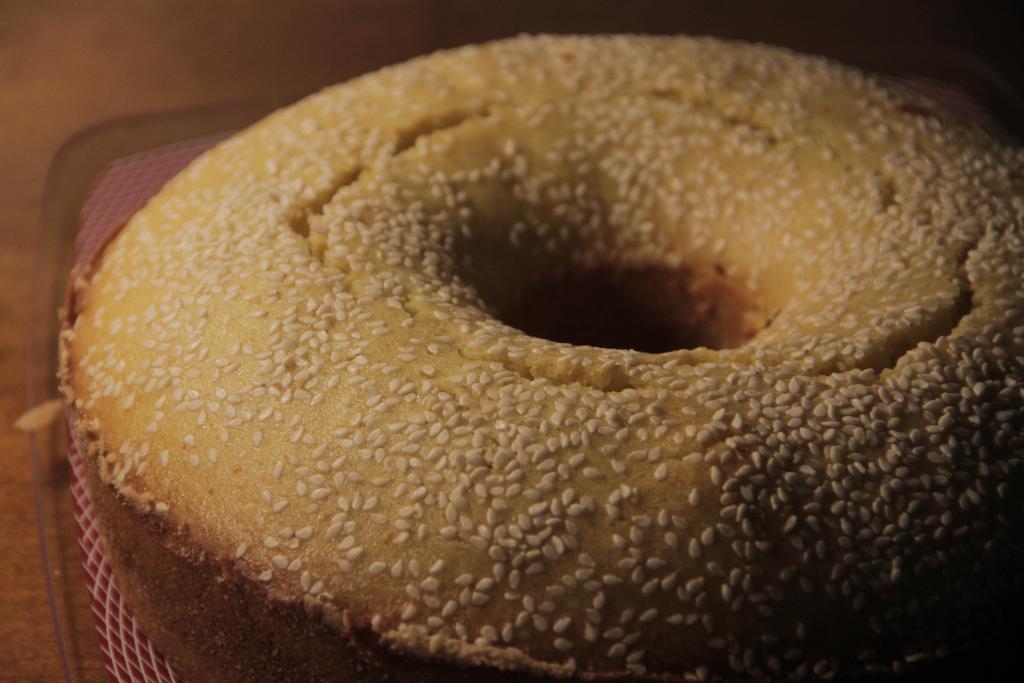Could you give a brief overview of what you see in this image? There are white color sesame seeds arranged on the doughnut which is placed on the cloth. Which is placed on the plate. And the plate is placed on the wooden table. 